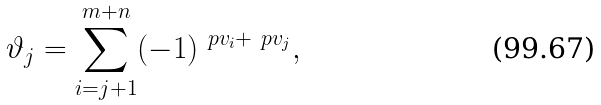Convert formula to latex. <formula><loc_0><loc_0><loc_500><loc_500>\vartheta _ { j } = \sum _ { i = j + 1 } ^ { m + n } ( - 1 ) ^ { \ p { v } _ { i } + \ p { v } _ { j } } ,</formula> 